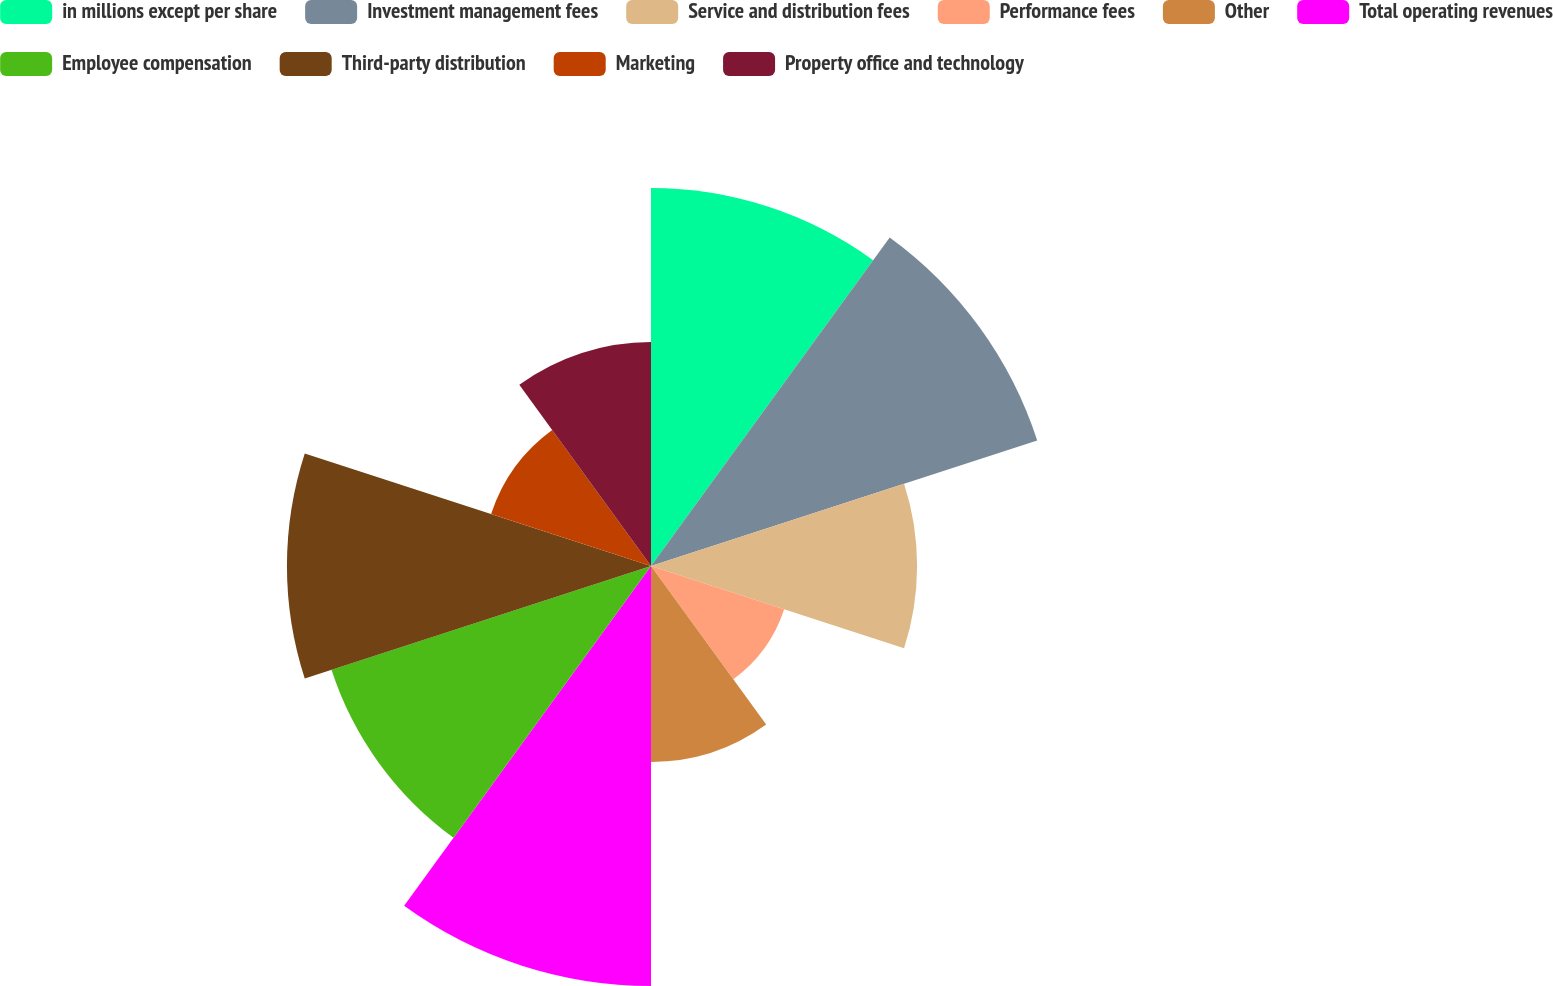<chart> <loc_0><loc_0><loc_500><loc_500><pie_chart><fcel>in millions except per share<fcel>Investment management fees<fcel>Service and distribution fees<fcel>Performance fees<fcel>Other<fcel>Total operating revenues<fcel>Employee compensation<fcel>Third-party distribution<fcel>Marketing<fcel>Property office and technology<nl><fcel>13.04%<fcel>14.01%<fcel>9.18%<fcel>4.83%<fcel>6.76%<fcel>14.49%<fcel>11.59%<fcel>12.56%<fcel>5.8%<fcel>7.73%<nl></chart> 